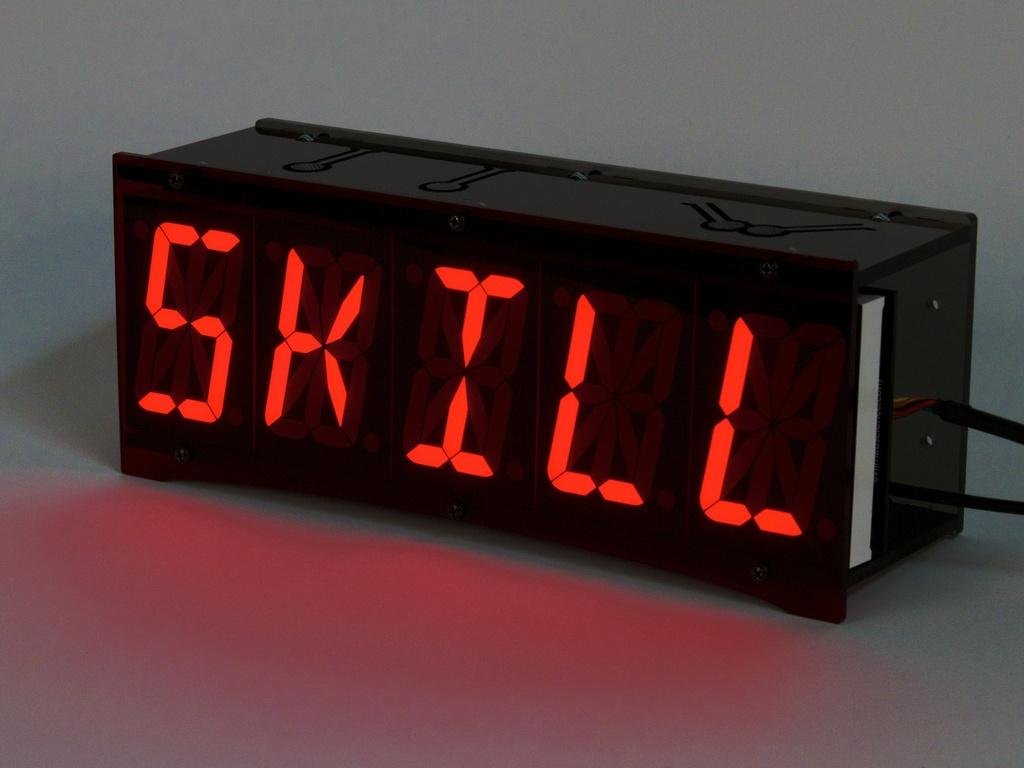<image>
Summarize the visual content of the image. Digital looking clockish rectangular black plastic piece with the words SKILL written out in red. 